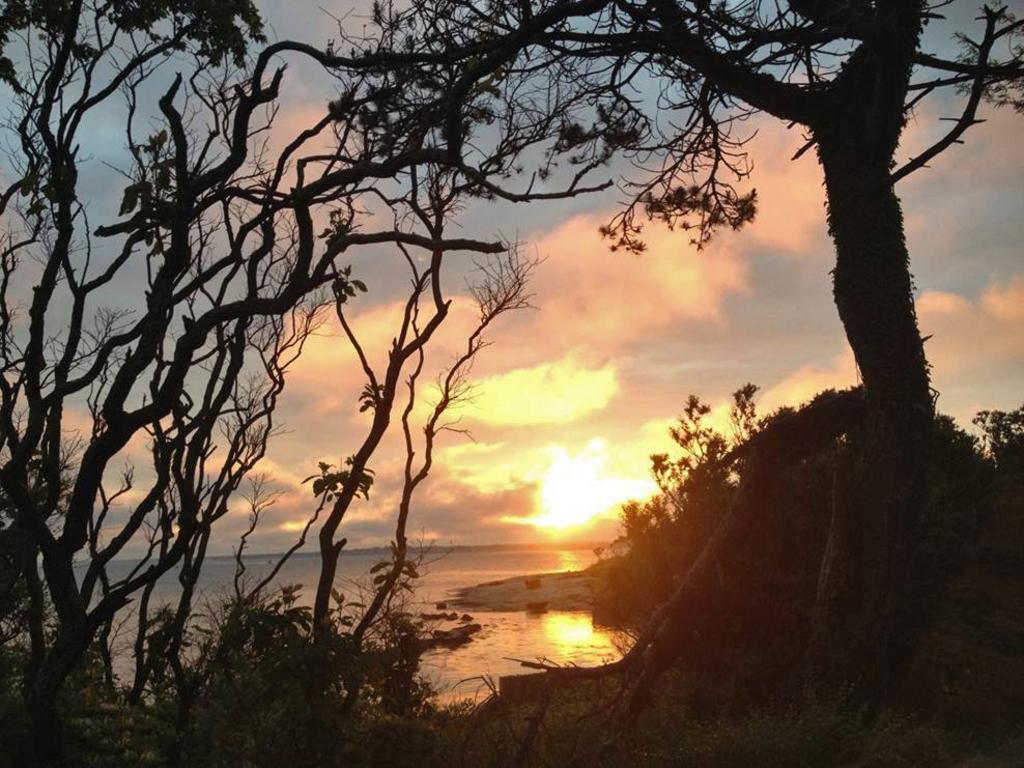How would you summarize this image in a sentence or two? We can see trees, plants and water. In the background we can see sky with clouds. 